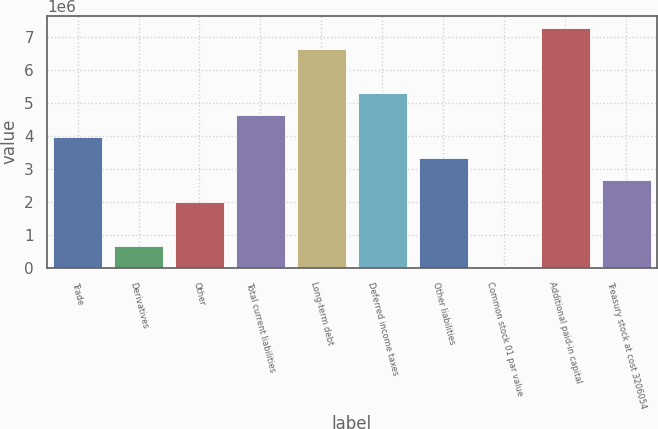Convert chart. <chart><loc_0><loc_0><loc_500><loc_500><bar_chart><fcel>Trade<fcel>Derivatives<fcel>Other<fcel>Total current liabilities<fcel>Long-term debt<fcel>Deferred income taxes<fcel>Other liabilities<fcel>Common stock 01 par value<fcel>Additional paid-in capital<fcel>Treasury stock at cost 3206054<nl><fcel>3.96944e+06<fcel>662788<fcel>1.98545e+06<fcel>4.63077e+06<fcel>6.61476e+06<fcel>5.2921e+06<fcel>3.30811e+06<fcel>1458<fcel>7.27609e+06<fcel>2.64678e+06<nl></chart> 